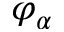<formula> <loc_0><loc_0><loc_500><loc_500>\varphi _ { \alpha }</formula> 